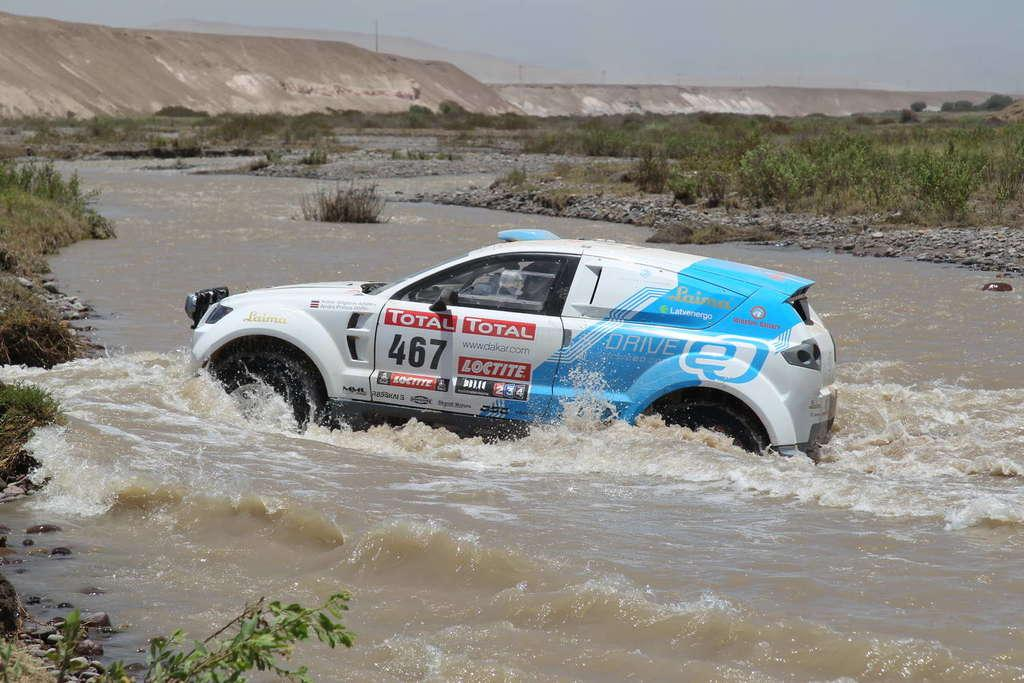What is the main subject of the image? There is a vehicle in the water. What can be seen in the background of the image? There are plants, the sky, poles, and other unspecified objects in the background of the image. What type of lunchroom can be seen in the image? There is no lunchroom present in the image. What thrilling activity is taking place in the image? There is no thrilling activity depicted in the image; it simply shows a vehicle in the water and the background elements. 